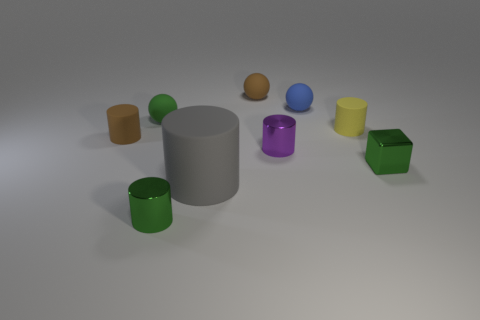Can you describe the texture of the objects in the image? Certainly! The objects in the image appear to have varying textures: some seem matte with a diffused appearance, while others are more reflective, suggesting a metallic finish. 